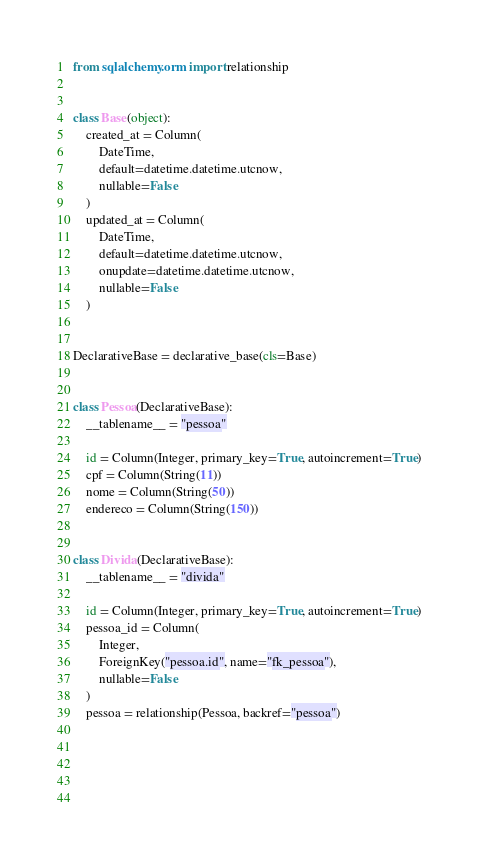Convert code to text. <code><loc_0><loc_0><loc_500><loc_500><_Python_>from sqlalchemy.orm import relationship


class Base(object):
    created_at = Column(
        DateTime,
        default=datetime.datetime.utcnow,
        nullable=False
    )
    updated_at = Column(
        DateTime,
        default=datetime.datetime.utcnow,
        onupdate=datetime.datetime.utcnow,
        nullable=False
    )


DeclarativeBase = declarative_base(cls=Base)


class Pessoa(DeclarativeBase):
    __tablename__ = "pessoa"

    id = Column(Integer, primary_key=True, autoincrement=True)
    cpf = Column(String(11))
    nome = Column(String(50))
    endereco = Column(String(150))


class Divida(DeclarativeBase):
    __tablename__ = "divida"

    id = Column(Integer, primary_key=True, autoincrement=True)
    pessoa_id = Column(
        Integer,
        ForeignKey("pessoa.id", name="fk_pessoa"),
        nullable=False
    )
    pessoa = relationship(Pessoa, backref="pessoa")




    
</code> 